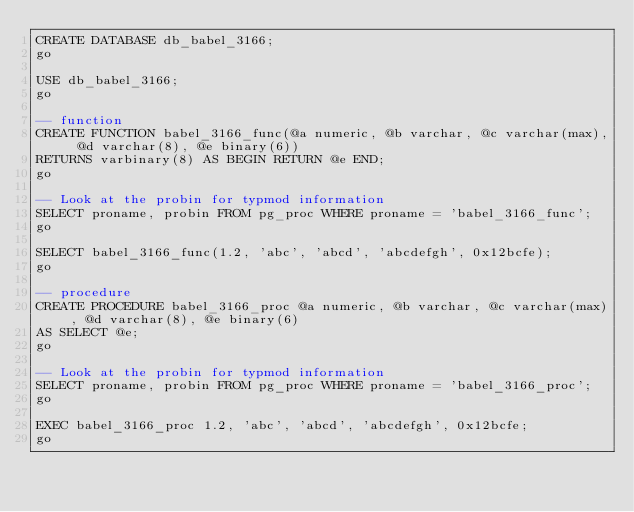<code> <loc_0><loc_0><loc_500><loc_500><_SQL_>CREATE DATABASE db_babel_3166;
go

USE db_babel_3166;
go

-- function
CREATE FUNCTION babel_3166_func(@a numeric, @b varchar, @c varchar(max), @d varchar(8), @e binary(6))
RETURNS varbinary(8) AS BEGIN RETURN @e END;
go

-- Look at the probin for typmod information
SELECT proname, probin FROM pg_proc WHERE proname = 'babel_3166_func';
go

SELECT babel_3166_func(1.2, 'abc', 'abcd', 'abcdefgh', 0x12bcfe);
go

-- procedure
CREATE PROCEDURE babel_3166_proc @a numeric, @b varchar, @c varchar(max), @d varchar(8), @e binary(6)
AS SELECT @e;
go

-- Look at the probin for typmod information
SELECT proname, probin FROM pg_proc WHERE proname = 'babel_3166_proc';
go

EXEC babel_3166_proc 1.2, 'abc', 'abcd', 'abcdefgh', 0x12bcfe;
go</code> 